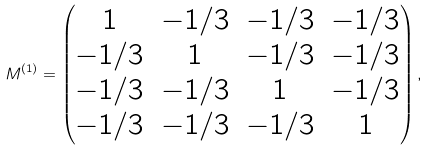Convert formula to latex. <formula><loc_0><loc_0><loc_500><loc_500>M ^ { ( 1 ) } = \begin{pmatrix} 1 & - 1 / 3 & - 1 / 3 & - 1 / 3 \\ - 1 / 3 & 1 & - 1 / 3 & - 1 / 3 \\ - 1 / 3 & - 1 / 3 & 1 & - 1 / 3 \\ - 1 / 3 & - 1 / 3 & - 1 / 3 & 1 \end{pmatrix} ,</formula> 